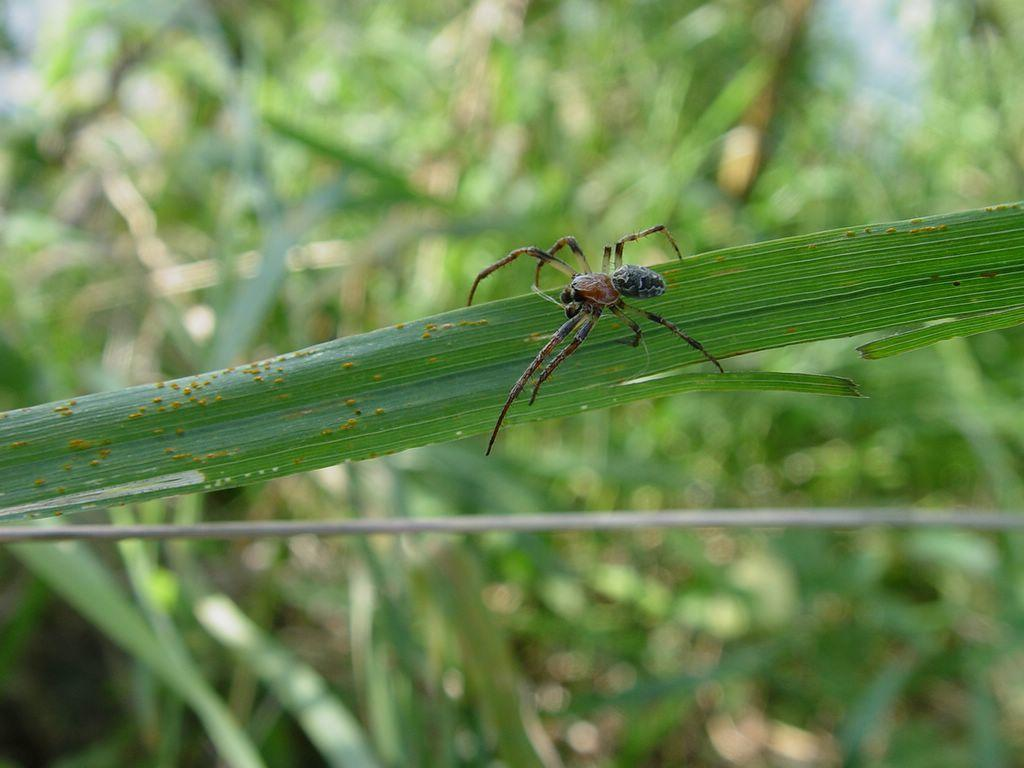What is present on the leaf in the image? There is an insect on a leaf in the image. What can be observed in the background of the image? The background of the image is green in color. What type of flesh can be seen on the cow in the image? There is no cow present in the image; it features an insect on a leaf with a green background. 